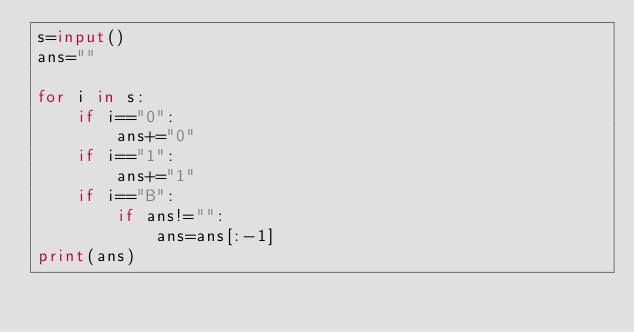Convert code to text. <code><loc_0><loc_0><loc_500><loc_500><_Python_>s=input()
ans=""

for i in s:
    if i=="0":
        ans+="0"
    if i=="1":
        ans+="1"
    if i=="B":
        if ans!="":
            ans=ans[:-1]
print(ans)</code> 